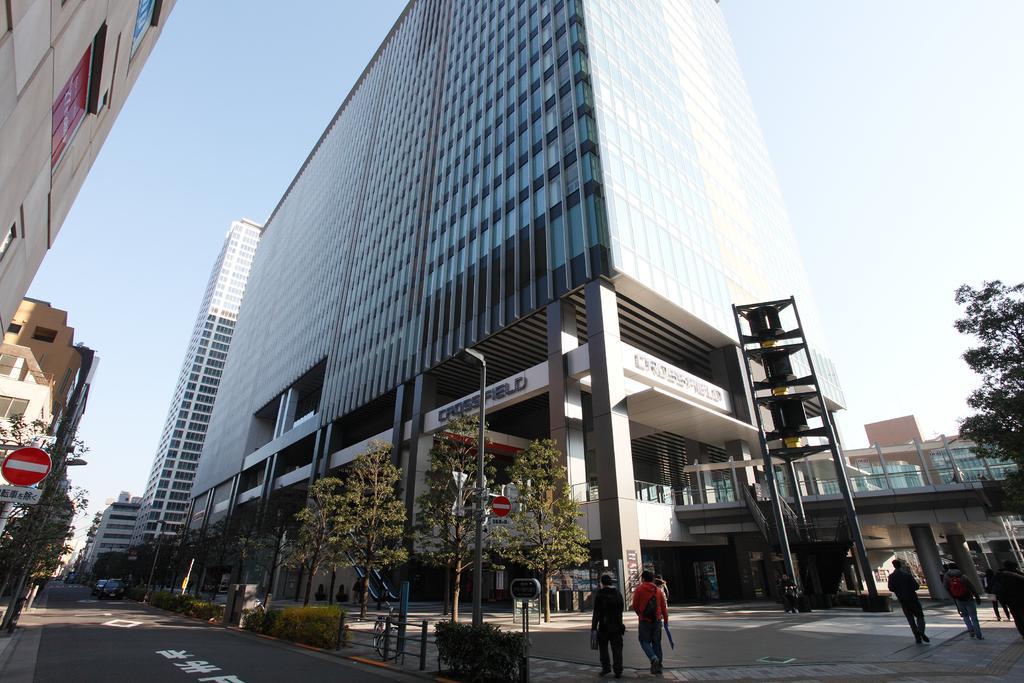Describe this image in one or two sentences. In this picture we can see some people are walking on the footpath, vehicles on the road, bicycle, sign boards, plants, buildings, trees, some objects and in the background we can see the sky. 